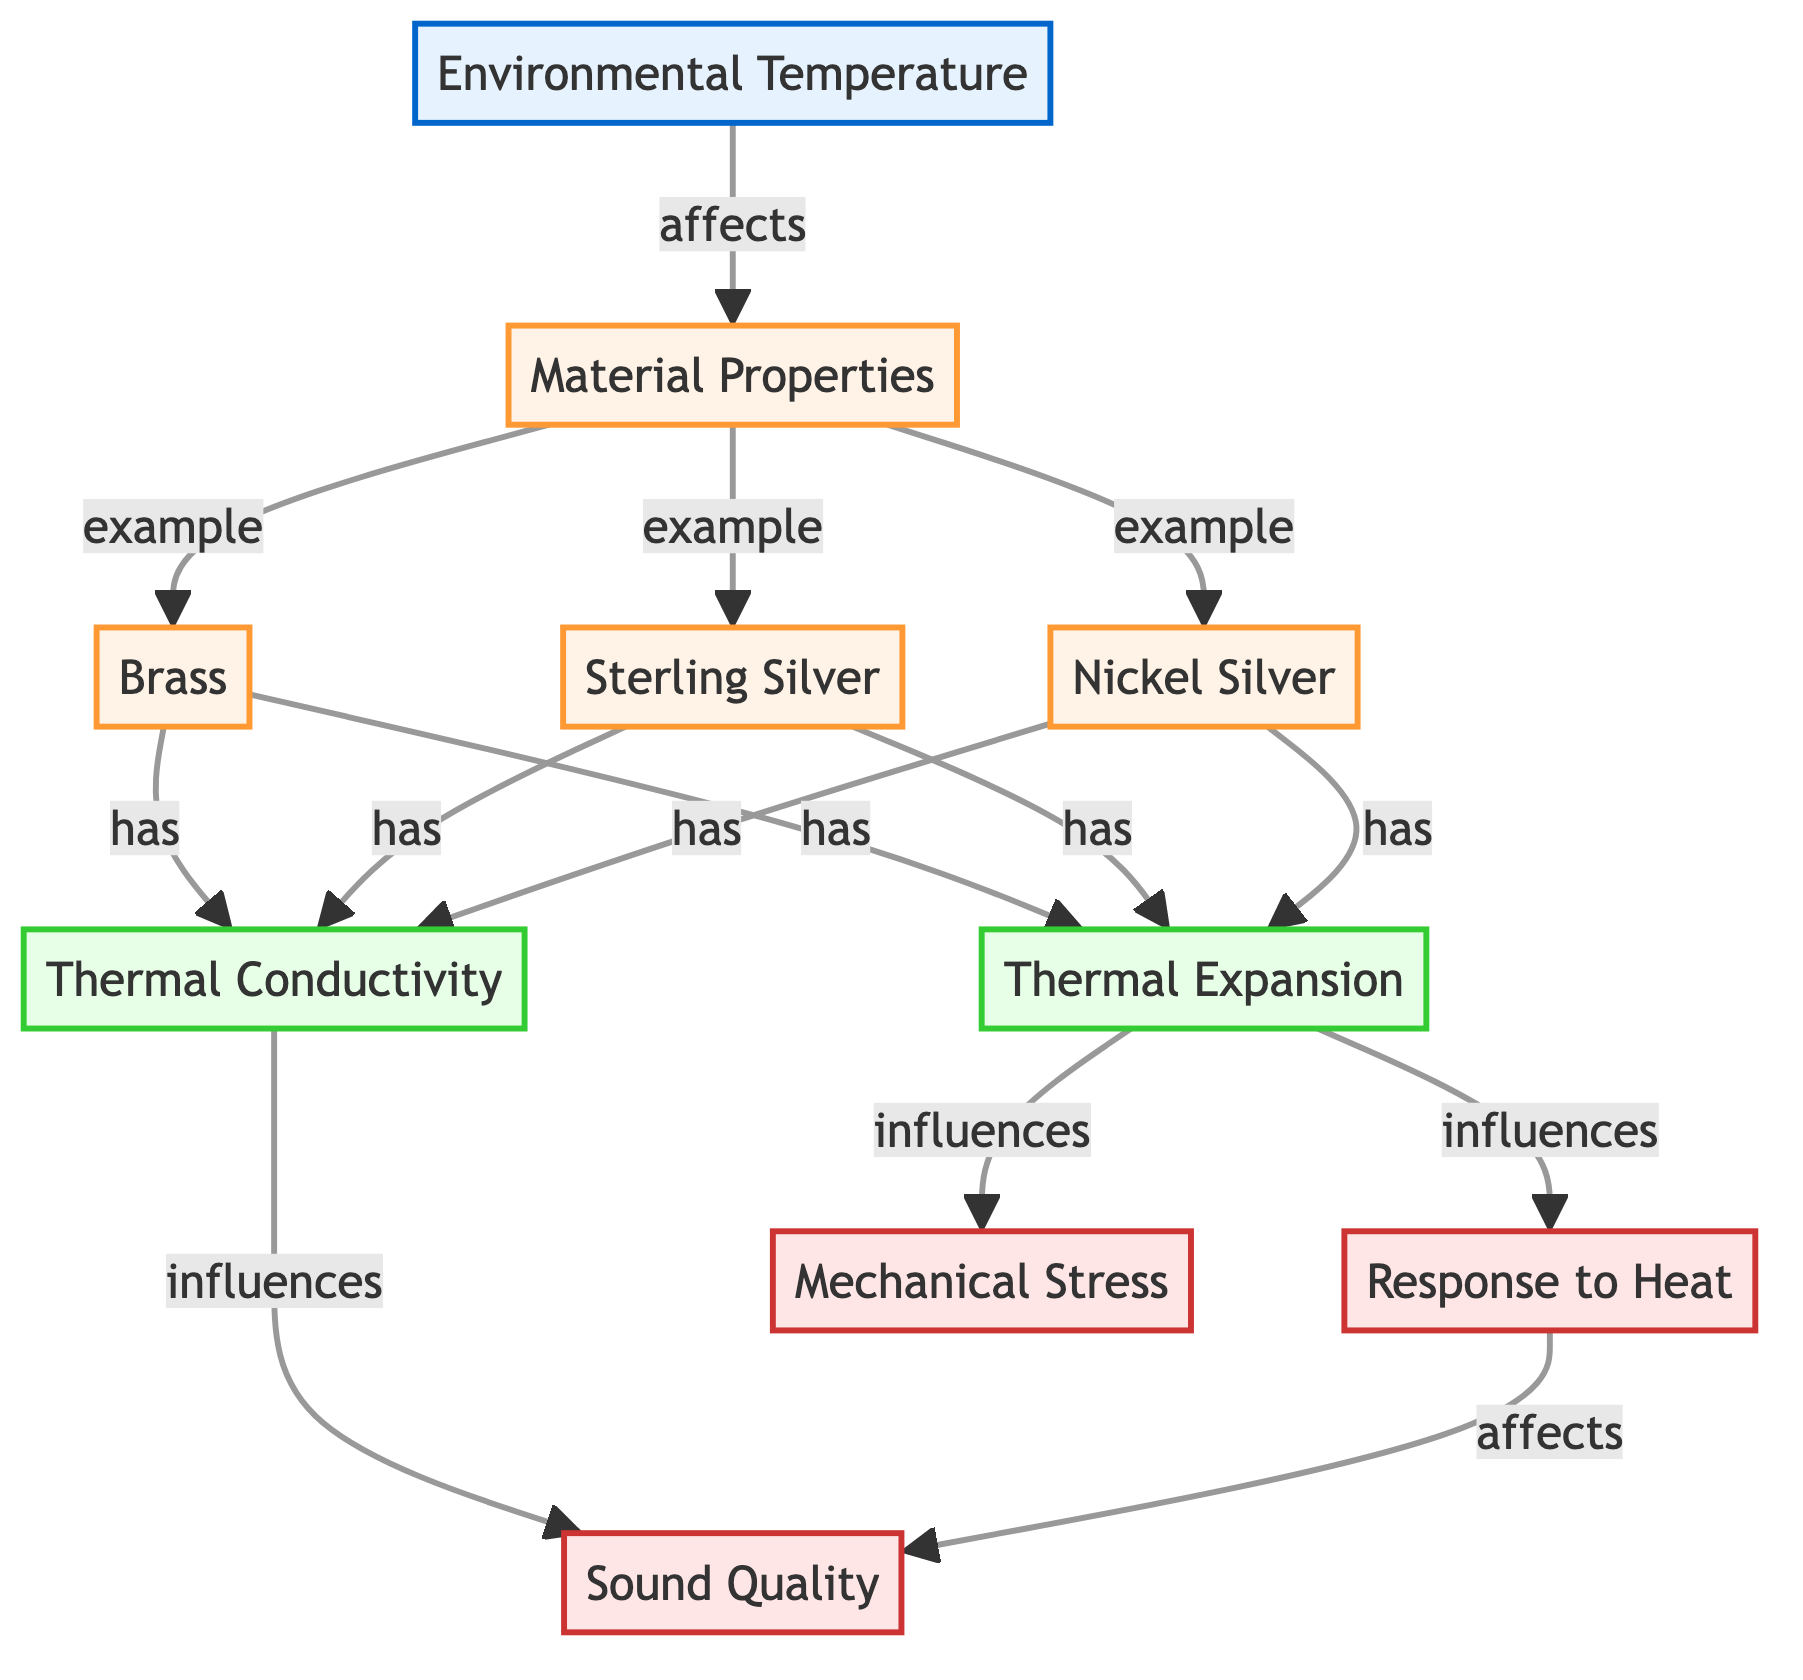What environmental factor affects material properties? The diagram indicates that "Environmental Temperature" influences "Material Properties." Thus, the environmental factor in question is temperature.
Answer: temperature How many materials are listed in the diagram? The diagram shows three materials: Brass, Sterling Silver, and Nickel Silver. Thus, the total count of materials is three.
Answer: 3 Which material has a property of thermal conductivity? According to the flowchart, all three materials (Brass, Sterling Silver, Nickel Silver) have the property of thermal conductivity listed under them. To answer, any of the materials can be an answer, but referring to specific examples helps.
Answer: Brass How does thermal expansion influence mechanical stress? The diagram shows that "Thermal Expansion" influences both "Response to Heat" and "Mechanical Stress." First, thermal expansion affects the response to heat, which then affects sound quality as a resultant. Then, "Mechanical Stress" is directly influenced, indicating a chain of dependencies in the flowchart.
Answer: influences What is the effect of thermal conductivity on sound quality? The diagram demonstrates that "Thermal Conductivity" influences "Sound Quality." This means that as thermal conductivity changes, the sound quality of the materials will also change, establishing a direct link between the two nodes.
Answer: influences Which material property is linked to sound quality? The diagram indicates that "Thermal Conductivity," which is a property associated with each material, influences "Sound Quality." This shows that sound quality depends particularly on how well the material conducts heat.
Answer: Thermal Conductivity What happens to sound quality when mechanical stress increases? The diagram states that "Mechanical Stress" influences sound quality. This delineates a potential worsening of sound quality when mechanical stress increases, showing a negative correlation between stress and sound quality.
Answer: affects Which materials exhibit thermal expansion? The diagram confirms that all three materials, Brass, Sterling Silver, and Nickel Silver, exhibit thermal expansion properties. This is explicit as all materials branch from "Material Properties" that indicate their respective characteristics.
Answer: Brass, Sterling Silver, Nickel Silver How many effects are shown in the diagram? The diagram includes three effects: "Sound Quality," "Response to Heat," and "Mechanical Stress." Each of these effects relates to properties or materials as per the flowchart. Thus, the count of effects is three.
Answer: 3 